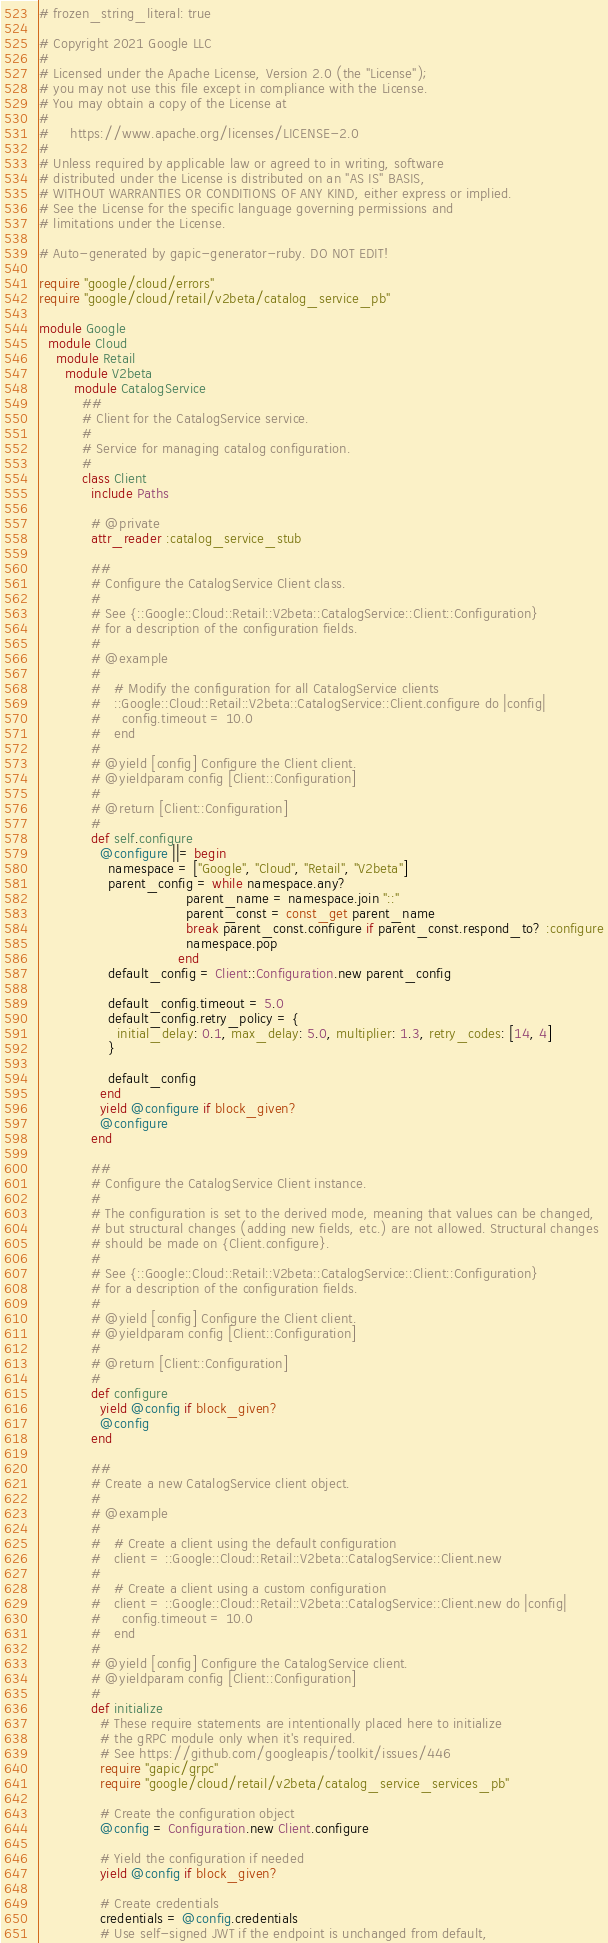Convert code to text. <code><loc_0><loc_0><loc_500><loc_500><_Ruby_># frozen_string_literal: true

# Copyright 2021 Google LLC
#
# Licensed under the Apache License, Version 2.0 (the "License");
# you may not use this file except in compliance with the License.
# You may obtain a copy of the License at
#
#     https://www.apache.org/licenses/LICENSE-2.0
#
# Unless required by applicable law or agreed to in writing, software
# distributed under the License is distributed on an "AS IS" BASIS,
# WITHOUT WARRANTIES OR CONDITIONS OF ANY KIND, either express or implied.
# See the License for the specific language governing permissions and
# limitations under the License.

# Auto-generated by gapic-generator-ruby. DO NOT EDIT!

require "google/cloud/errors"
require "google/cloud/retail/v2beta/catalog_service_pb"

module Google
  module Cloud
    module Retail
      module V2beta
        module CatalogService
          ##
          # Client for the CatalogService service.
          #
          # Service for managing catalog configuration.
          #
          class Client
            include Paths

            # @private
            attr_reader :catalog_service_stub

            ##
            # Configure the CatalogService Client class.
            #
            # See {::Google::Cloud::Retail::V2beta::CatalogService::Client::Configuration}
            # for a description of the configuration fields.
            #
            # @example
            #
            #   # Modify the configuration for all CatalogService clients
            #   ::Google::Cloud::Retail::V2beta::CatalogService::Client.configure do |config|
            #     config.timeout = 10.0
            #   end
            #
            # @yield [config] Configure the Client client.
            # @yieldparam config [Client::Configuration]
            #
            # @return [Client::Configuration]
            #
            def self.configure
              @configure ||= begin
                namespace = ["Google", "Cloud", "Retail", "V2beta"]
                parent_config = while namespace.any?
                                  parent_name = namespace.join "::"
                                  parent_const = const_get parent_name
                                  break parent_const.configure if parent_const.respond_to? :configure
                                  namespace.pop
                                end
                default_config = Client::Configuration.new parent_config

                default_config.timeout = 5.0
                default_config.retry_policy = {
                  initial_delay: 0.1, max_delay: 5.0, multiplier: 1.3, retry_codes: [14, 4]
                }

                default_config
              end
              yield @configure if block_given?
              @configure
            end

            ##
            # Configure the CatalogService Client instance.
            #
            # The configuration is set to the derived mode, meaning that values can be changed,
            # but structural changes (adding new fields, etc.) are not allowed. Structural changes
            # should be made on {Client.configure}.
            #
            # See {::Google::Cloud::Retail::V2beta::CatalogService::Client::Configuration}
            # for a description of the configuration fields.
            #
            # @yield [config] Configure the Client client.
            # @yieldparam config [Client::Configuration]
            #
            # @return [Client::Configuration]
            #
            def configure
              yield @config if block_given?
              @config
            end

            ##
            # Create a new CatalogService client object.
            #
            # @example
            #
            #   # Create a client using the default configuration
            #   client = ::Google::Cloud::Retail::V2beta::CatalogService::Client.new
            #
            #   # Create a client using a custom configuration
            #   client = ::Google::Cloud::Retail::V2beta::CatalogService::Client.new do |config|
            #     config.timeout = 10.0
            #   end
            #
            # @yield [config] Configure the CatalogService client.
            # @yieldparam config [Client::Configuration]
            #
            def initialize
              # These require statements are intentionally placed here to initialize
              # the gRPC module only when it's required.
              # See https://github.com/googleapis/toolkit/issues/446
              require "gapic/grpc"
              require "google/cloud/retail/v2beta/catalog_service_services_pb"

              # Create the configuration object
              @config = Configuration.new Client.configure

              # Yield the configuration if needed
              yield @config if block_given?

              # Create credentials
              credentials = @config.credentials
              # Use self-signed JWT if the endpoint is unchanged from default,</code> 